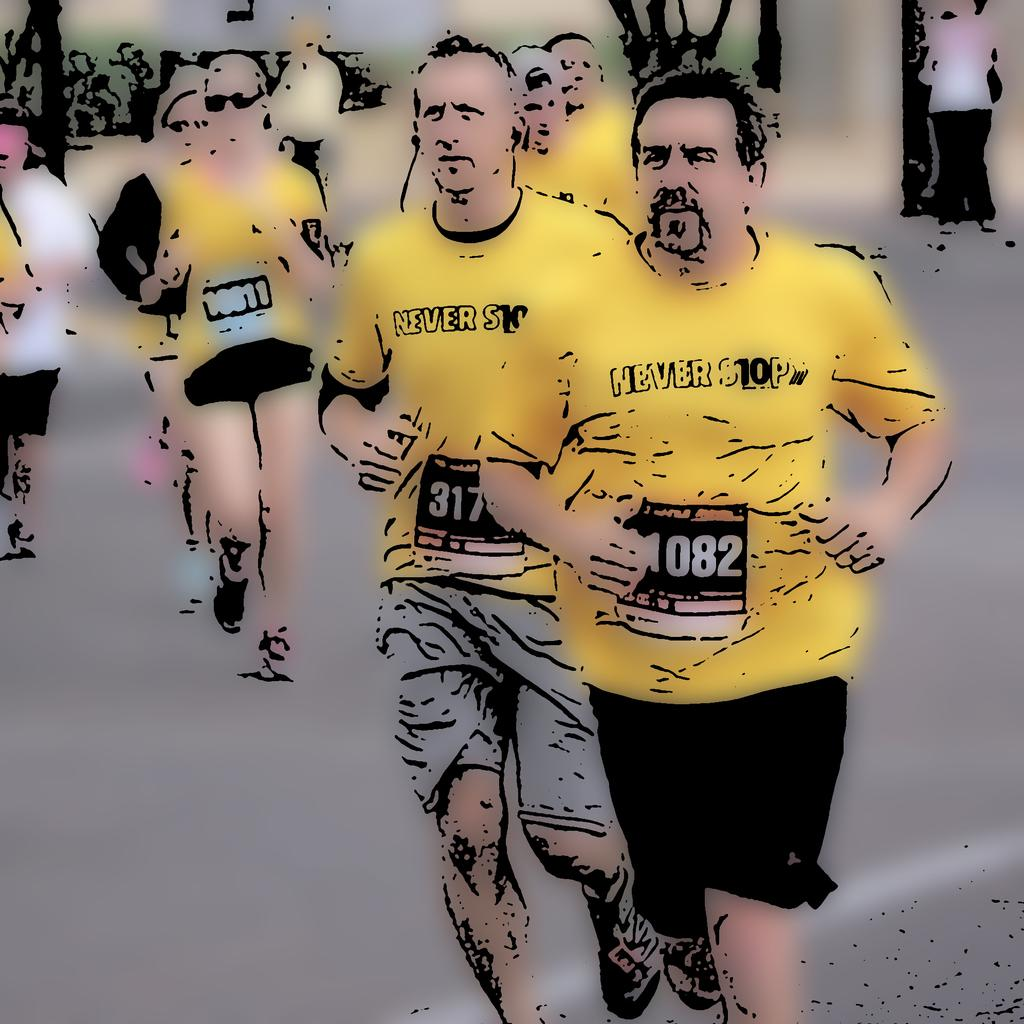What is happening in the image? There is a group of people in the image, and they are running on the road. What are the people wearing? The people are wearing yellow and black color dresses. Is there any smoke coming from the locket worn by one of the runners in the image? There is no mention of a locket or smoke in the image. The image only shows a group of people running on the road while wearing yellow and black color dresses. 